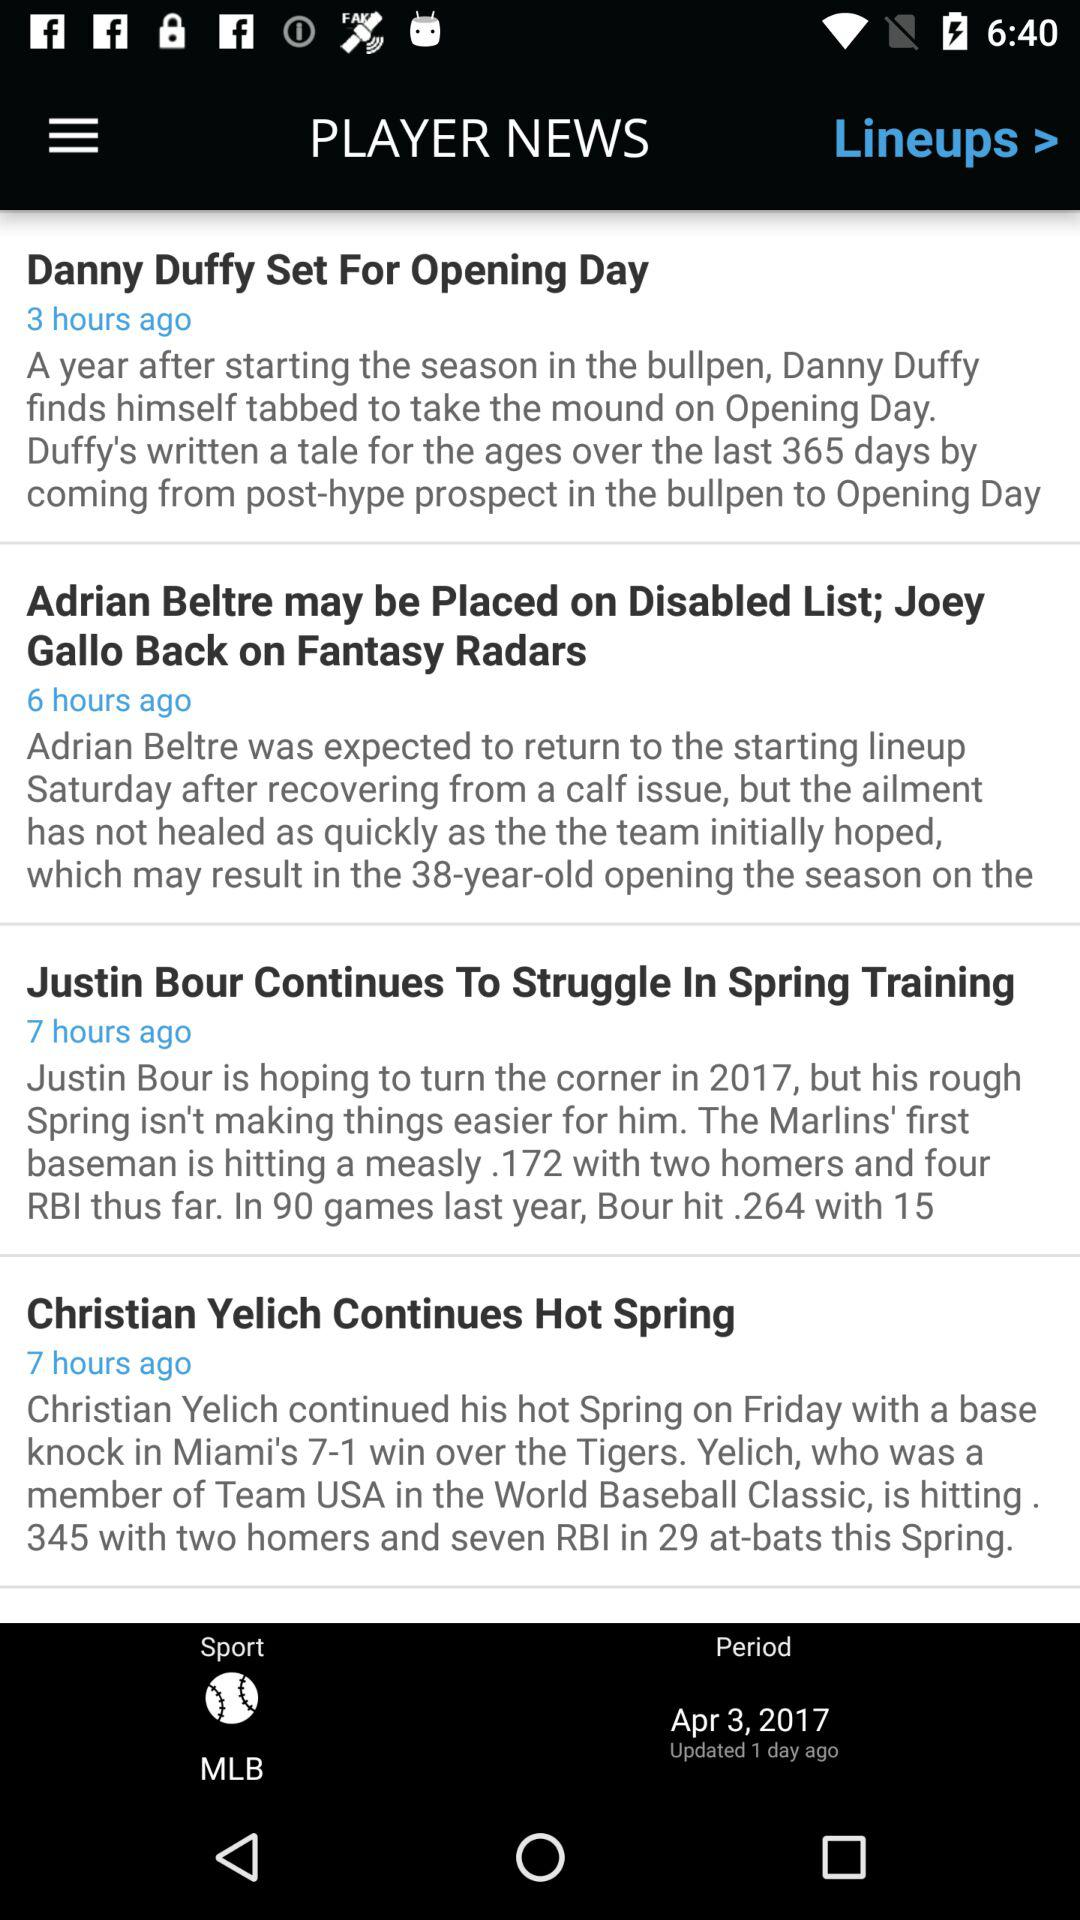When was the last update done? The last update was done 1 day ago. 